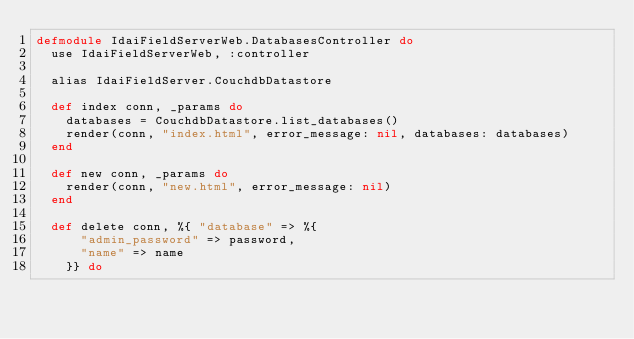Convert code to text. <code><loc_0><loc_0><loc_500><loc_500><_Elixir_>defmodule IdaiFieldServerWeb.DatabasesController do
  use IdaiFieldServerWeb, :controller

  alias IdaiFieldServer.CouchdbDatastore

  def index conn, _params do
    databases = CouchdbDatastore.list_databases()
    render(conn, "index.html", error_message: nil, databases: databases)
  end

  def new conn, _params do
    render(conn, "new.html", error_message: nil)
  end

  def delete conn, %{ "database" => %{
      "admin_password" => password,
      "name" => name
    }} do
</code> 